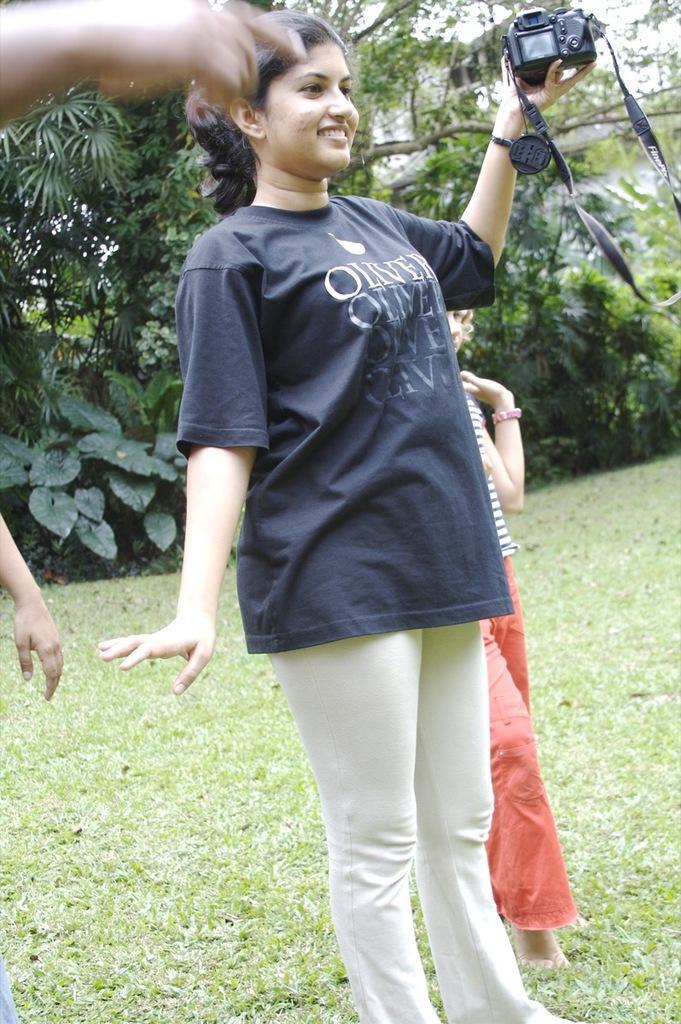In one or two sentences, can you explain what this image depicts? In this image we can see a woman is standing and smiling, and holding the camera in her hands, and at back a person is standing on the grass, and at back here are the trees. 